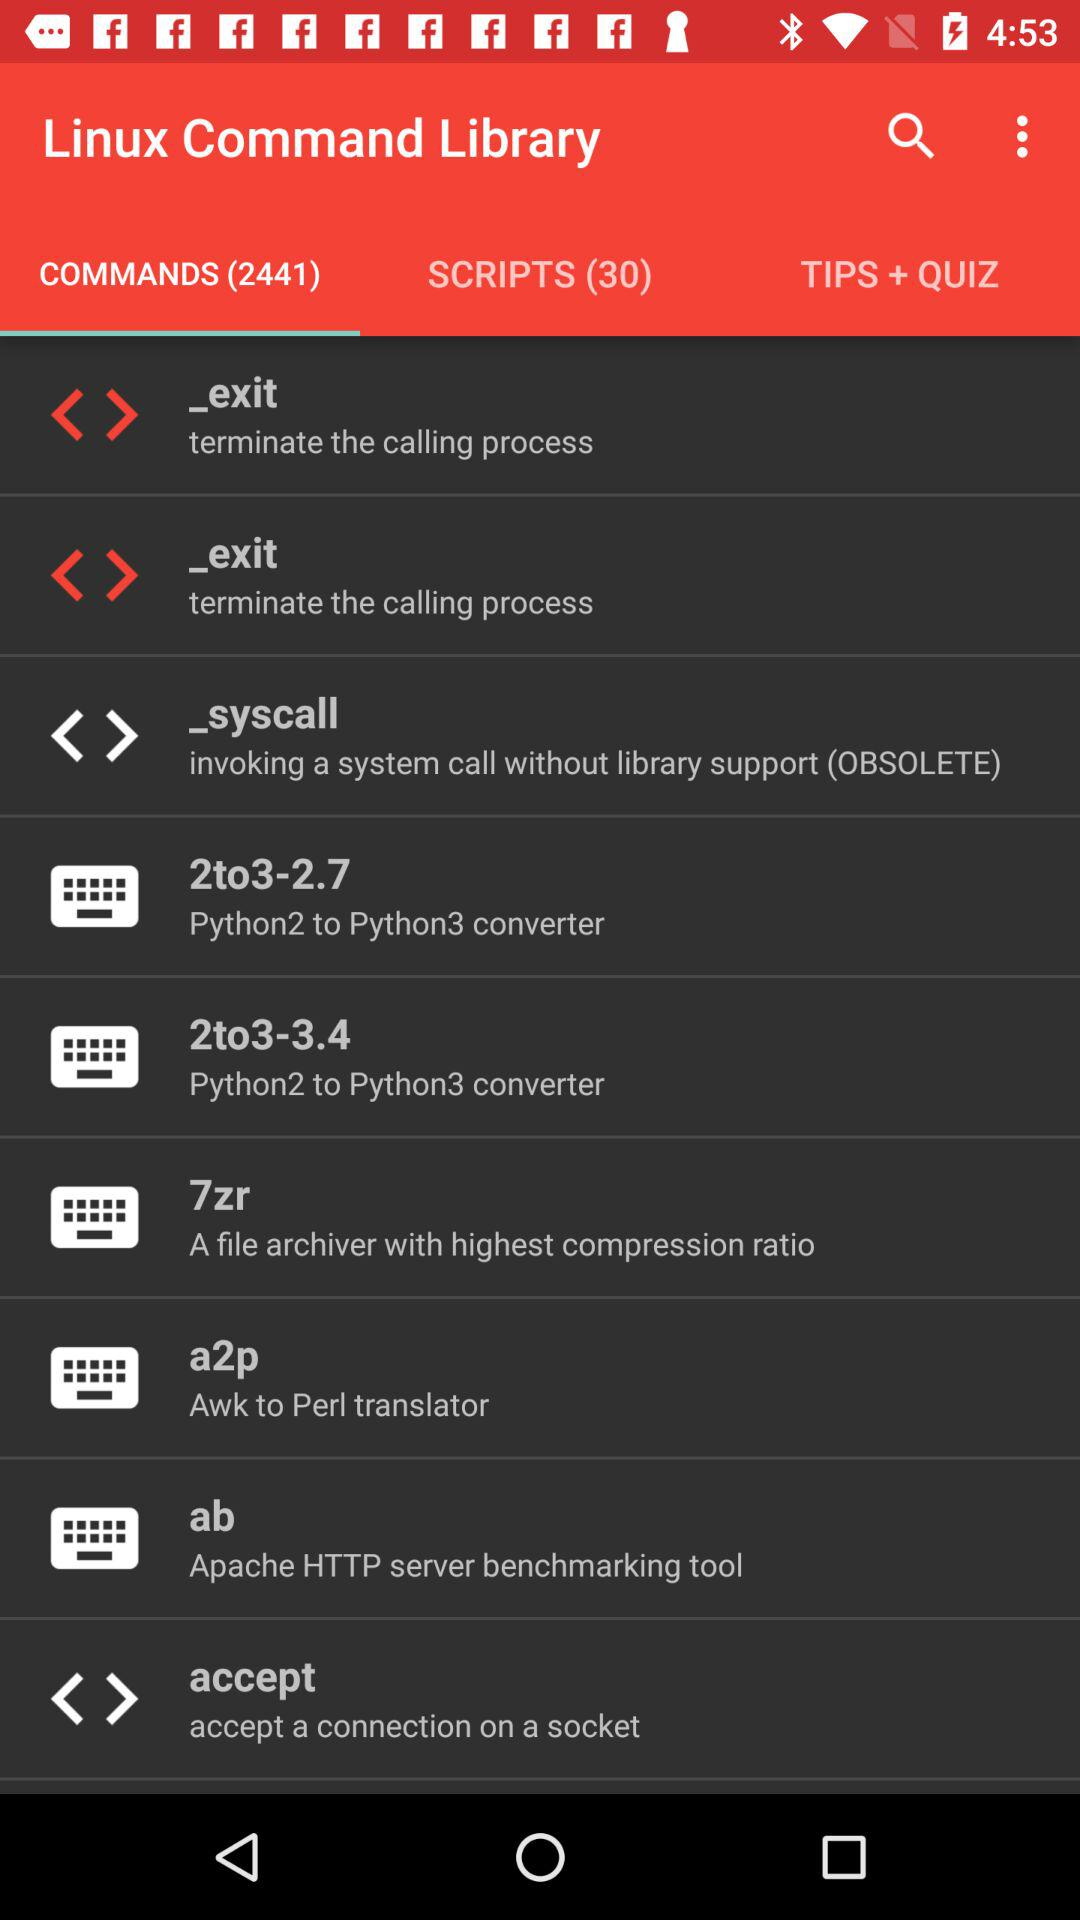Which tab are we on? You are on the "COMMANDS (2441)" tab. 